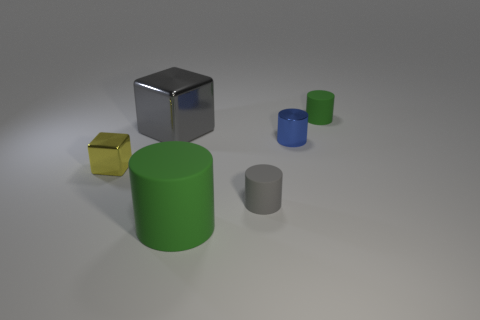Is the yellow object the same shape as the big gray metallic object?
Keep it short and to the point. Yes. What color is the object that is the same size as the gray block?
Keep it short and to the point. Green. Are there any rubber objects that have the same shape as the blue metallic object?
Offer a very short reply. Yes. The tiny metallic thing on the left side of the big object that is on the left side of the large cylinder is what color?
Provide a succinct answer. Yellow. Are there more cylinders than big cubes?
Give a very brief answer. Yes. What number of blue shiny objects have the same size as the yellow metallic thing?
Offer a terse response. 1. Does the small gray object have the same material as the block that is in front of the shiny cylinder?
Make the answer very short. No. Is the number of blue things less than the number of blue matte spheres?
Offer a very short reply. No. Is there any other thing that is the same color as the big cube?
Your response must be concise. Yes. The small yellow thing that is made of the same material as the big gray block is what shape?
Your response must be concise. Cube. 